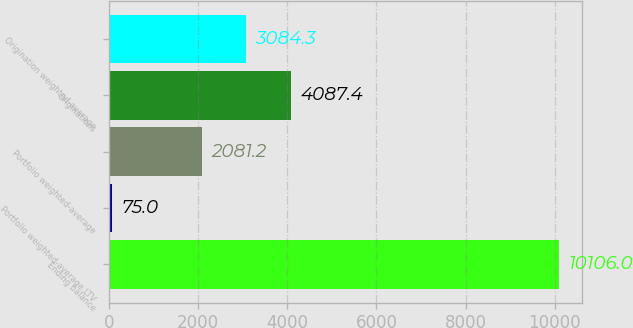Convert chart to OTSL. <chart><loc_0><loc_0><loc_500><loc_500><bar_chart><fcel>Ending balance<fcel>Portfolio weighted-average LTV<fcel>Portfolio weighted-average<fcel>Originations<fcel>Origination weighted-average<nl><fcel>10106<fcel>75<fcel>2081.2<fcel>4087.4<fcel>3084.3<nl></chart> 